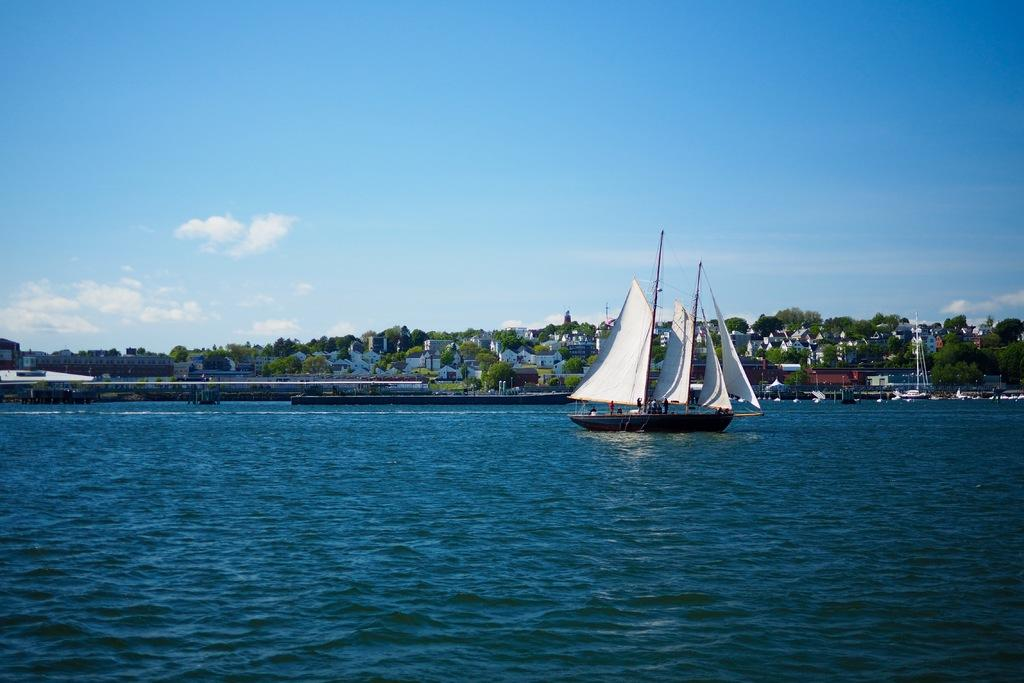What is located in the water in the image? There is a boat in the water in the image. What can be seen in the background of the image? There are many buildings and trees visible in the image. What is the color of the sky in the image? The sky is pale blue in the image. What type of utensil is used to serve the buildings in the image? There are no utensils present in the image, and the buildings are not being served. 